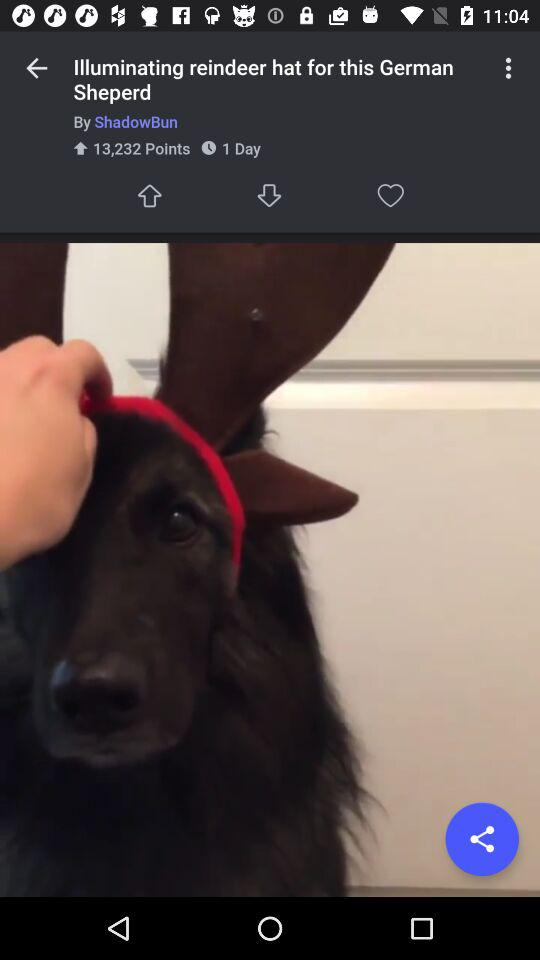Who posted the post? The post was posted by "ShadowBun". 